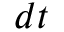<formula> <loc_0><loc_0><loc_500><loc_500>d t</formula> 